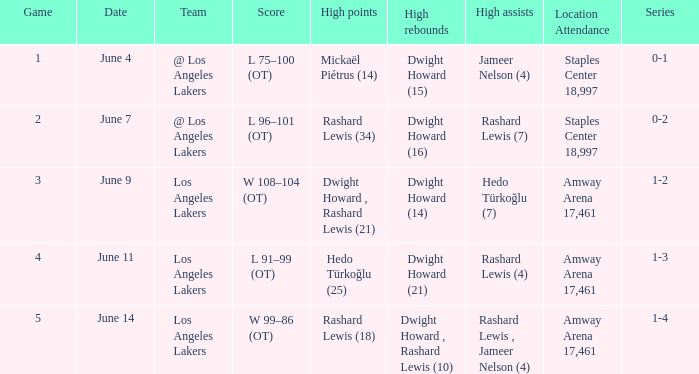On june 7, which series is being referred to? 0-2. 